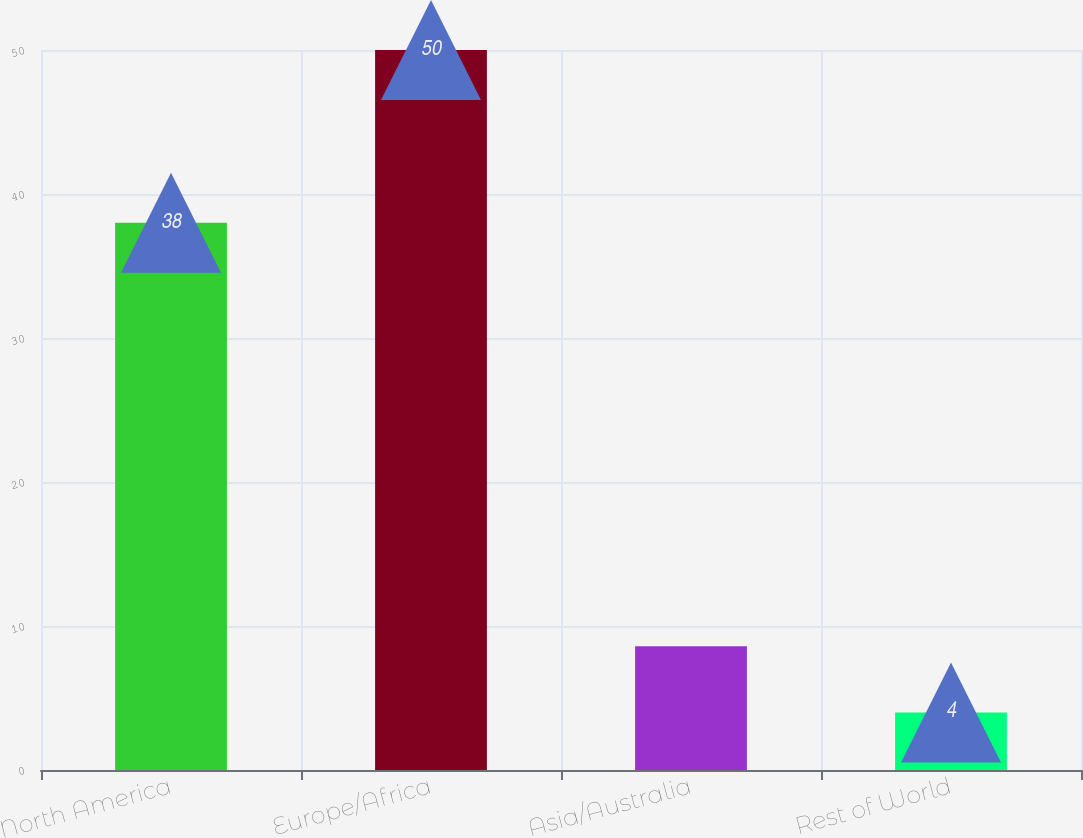Convert chart to OTSL. <chart><loc_0><loc_0><loc_500><loc_500><bar_chart><fcel>North America<fcel>Europe/Africa<fcel>Asia/Australia<fcel>Rest of World<nl><fcel>38<fcel>50<fcel>8.6<fcel>4<nl></chart> 